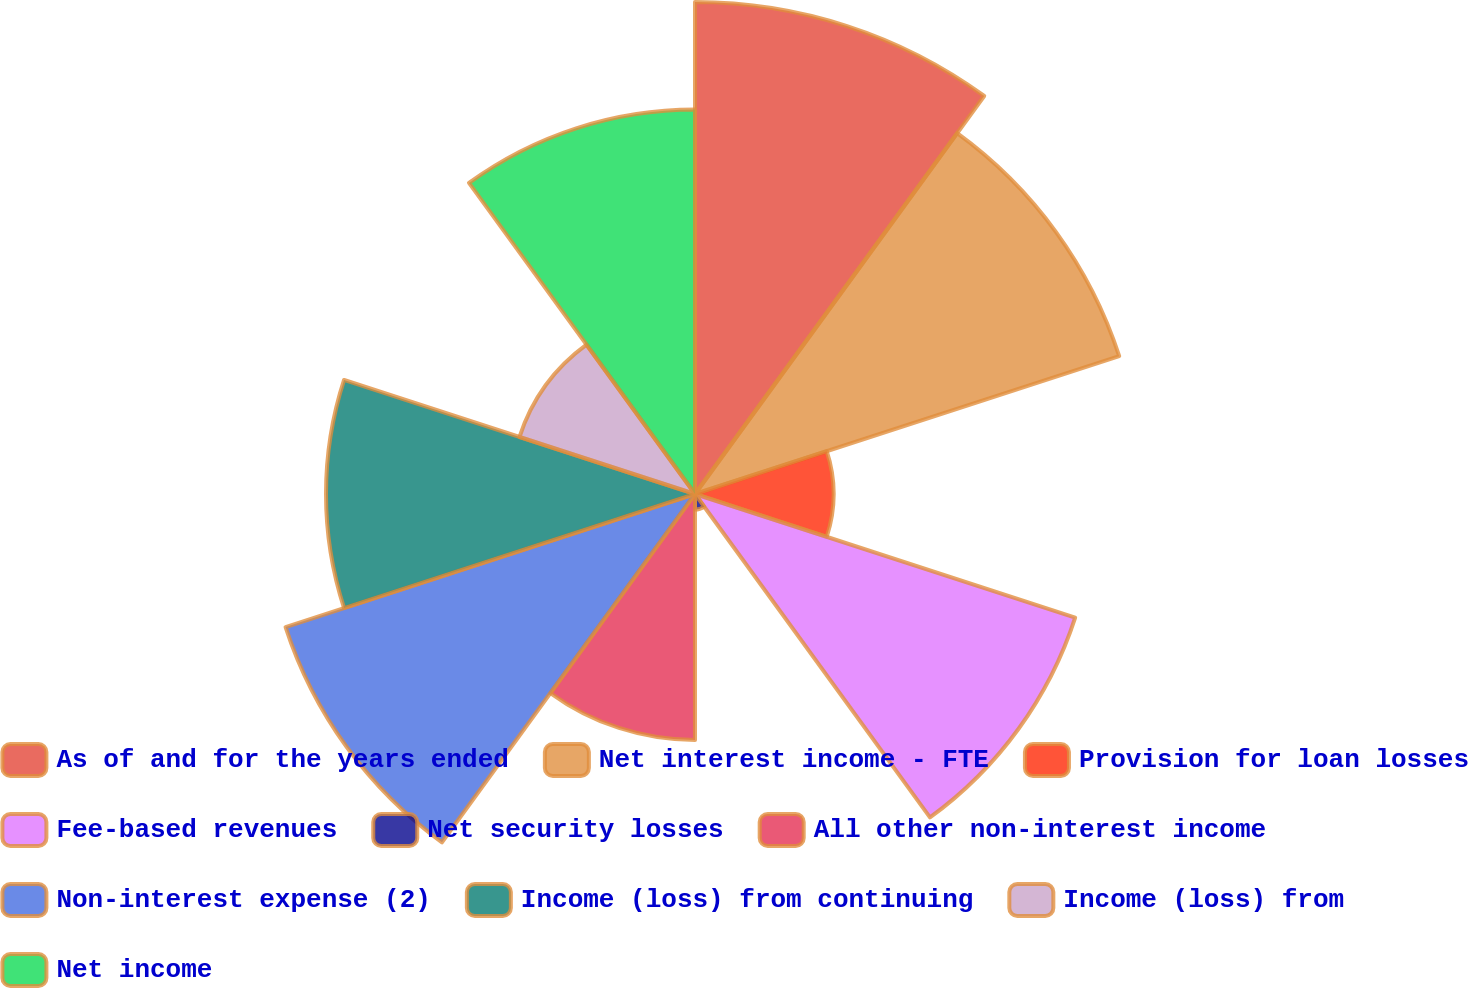<chart> <loc_0><loc_0><loc_500><loc_500><pie_chart><fcel>As of and for the years ended<fcel>Net interest income - FTE<fcel>Provision for loan losses<fcel>Fee-based revenues<fcel>Net security losses<fcel>All other non-interest income<fcel>Non-interest expense (2)<fcel>Income (loss) from continuing<fcel>Income (loss) from<fcel>Net income<nl><fcel>15.84%<fcel>14.36%<fcel>4.46%<fcel>12.87%<fcel>0.5%<fcel>7.92%<fcel>13.86%<fcel>11.88%<fcel>5.94%<fcel>12.38%<nl></chart> 